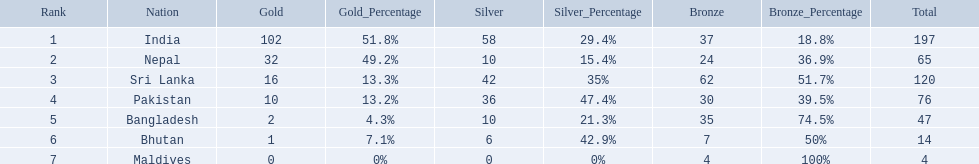Which countries won medals? India, Nepal, Sri Lanka, Pakistan, Bangladesh, Bhutan, Maldives. Which won the most? India. Which won the fewest? Maldives. How many gold medals were won by the teams? 102, 32, 16, 10, 2, 1, 0. What country won no gold medals? Maldives. 